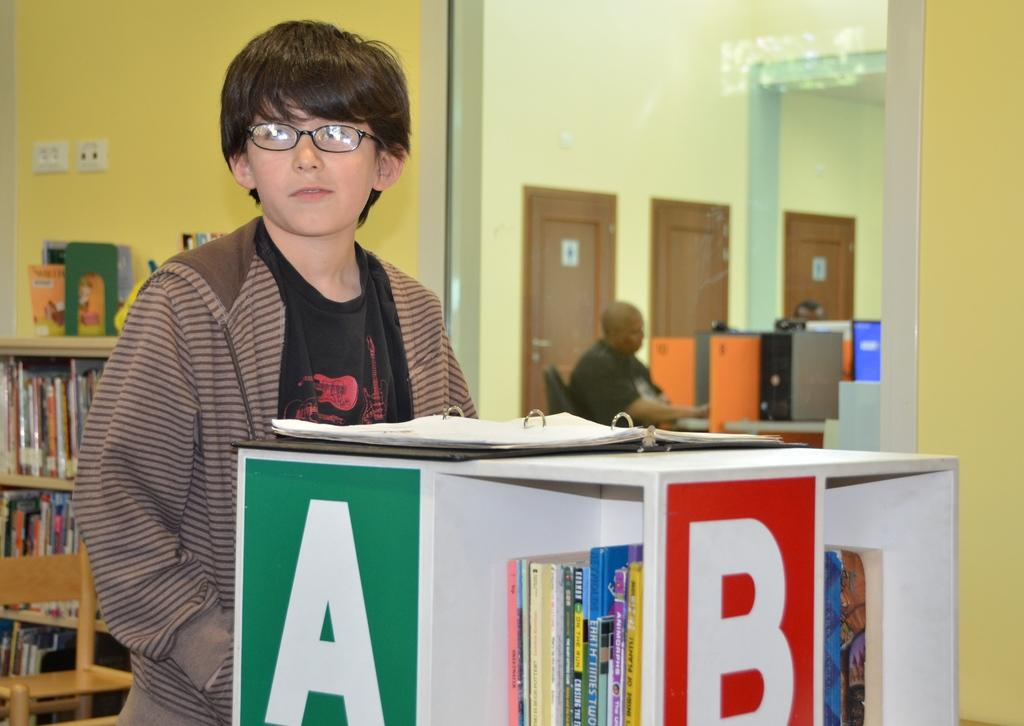<image>
Describe the image concisely. A boy with glasses stands next to library shelves labeled A and B. 